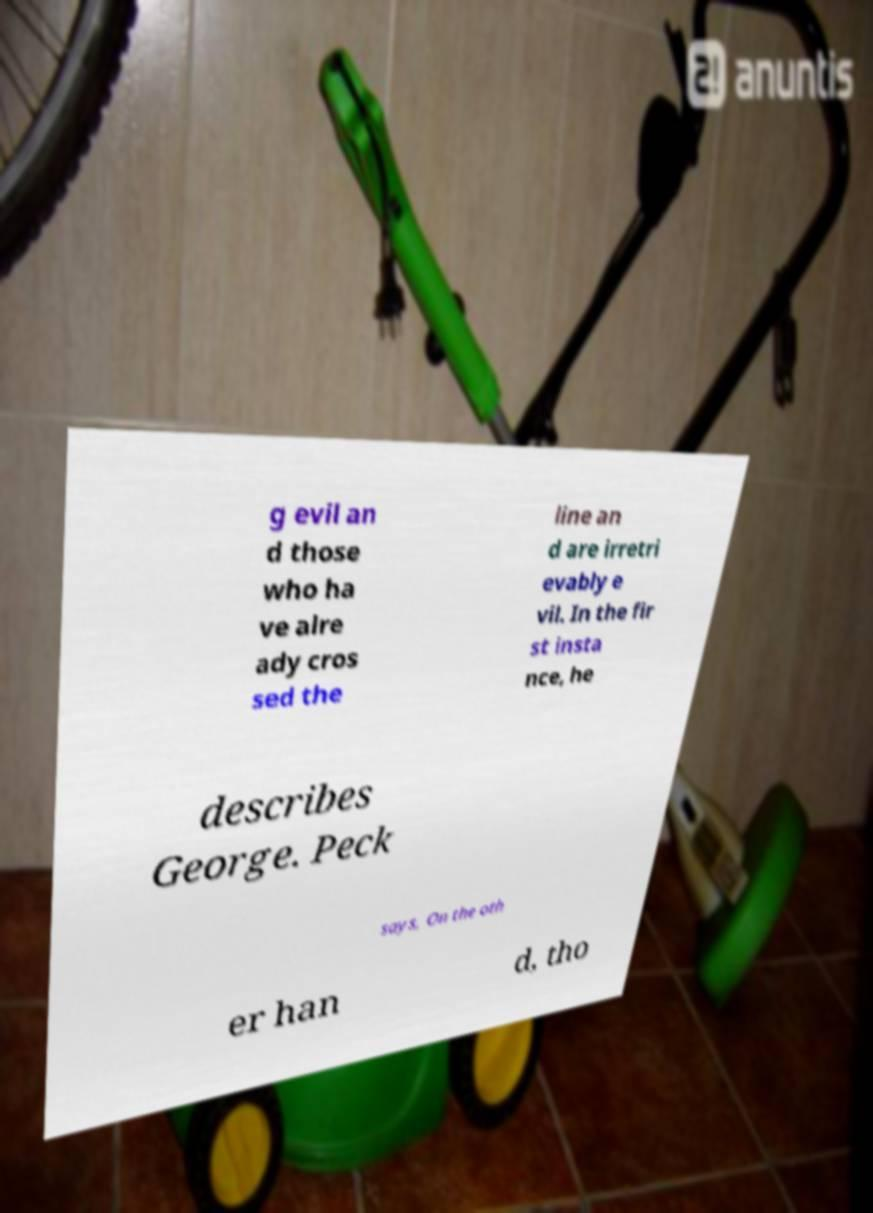Can you accurately transcribe the text from the provided image for me? g evil an d those who ha ve alre ady cros sed the line an d are irretri evably e vil. In the fir st insta nce, he describes George. Peck says, On the oth er han d, tho 